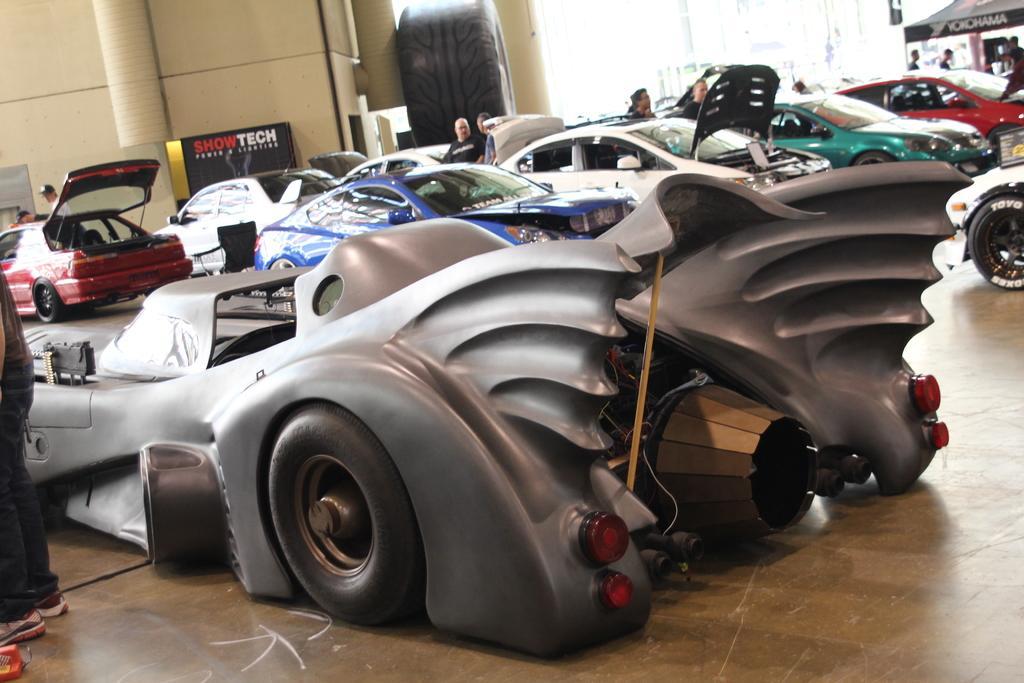Can you describe this image briefly? In this image there are vehicles and we can see people. On the right there is a tent. In the background there is a wall. 